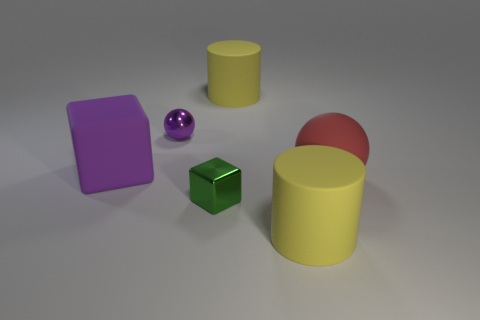Add 2 big balls. How many objects exist? 8 Subtract 0 blue spheres. How many objects are left? 6 Subtract all balls. How many objects are left? 4 Subtract all large cubes. Subtract all yellow things. How many objects are left? 3 Add 4 yellow things. How many yellow things are left? 6 Add 4 yellow cylinders. How many yellow cylinders exist? 6 